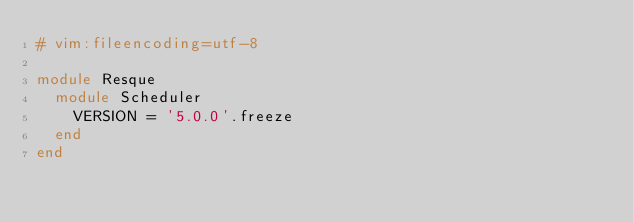<code> <loc_0><loc_0><loc_500><loc_500><_Ruby_># vim:fileencoding=utf-8

module Resque
  module Scheduler
    VERSION = '5.0.0'.freeze
  end
end
</code> 